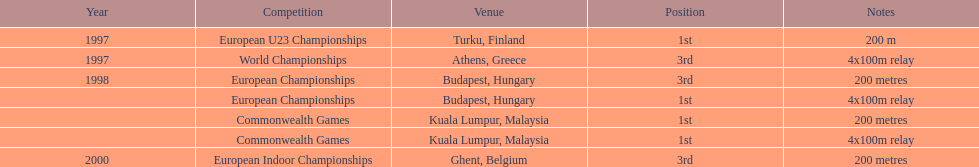In what year between 1997 and 2000 did julian golding, the sprinter representing the united kingdom and england finish first in both the 4 x 100 m relay and the 200 metres race? 1998. 